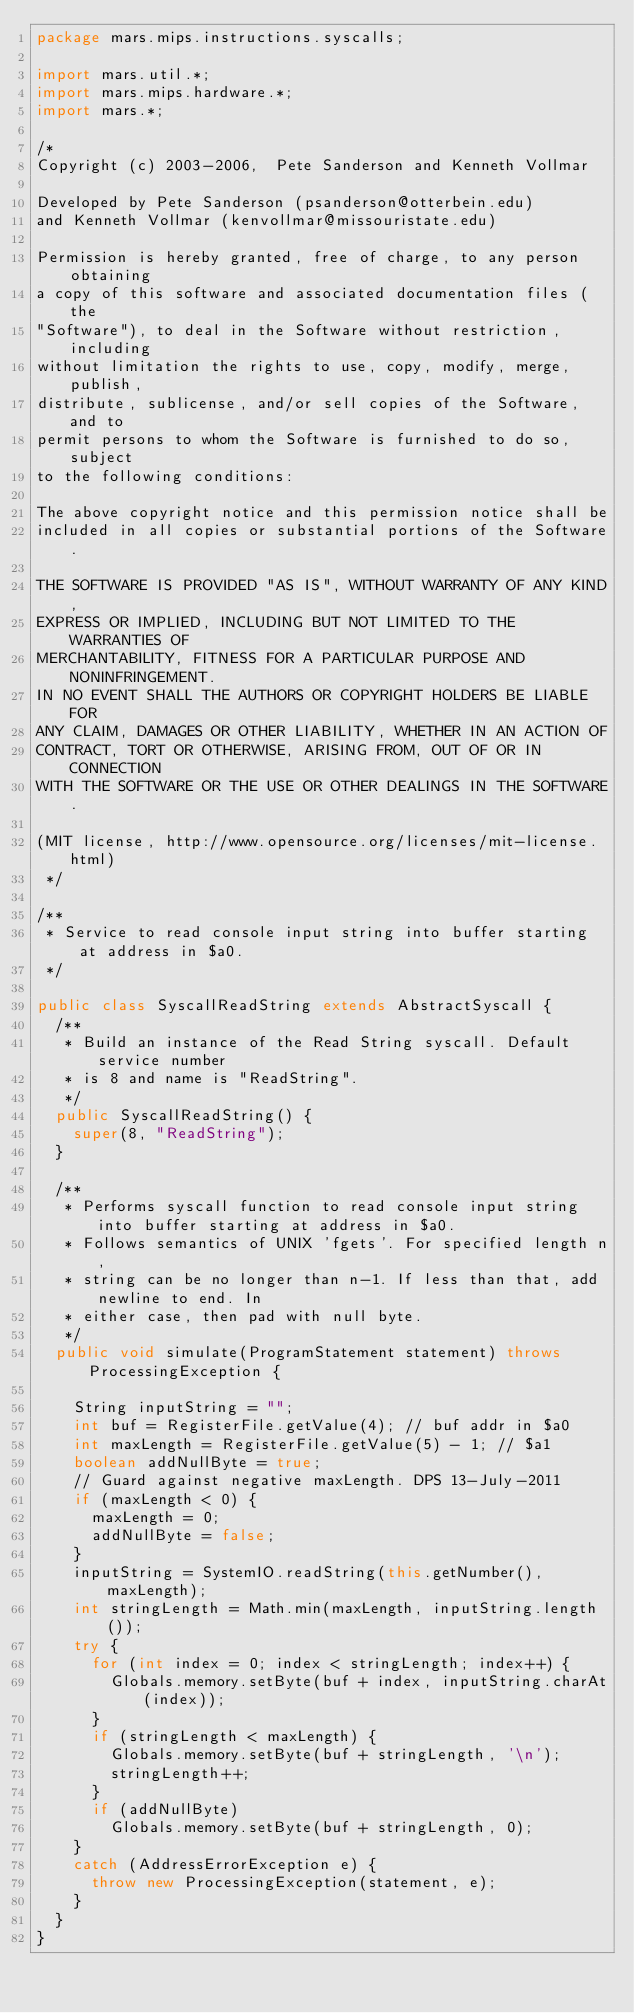<code> <loc_0><loc_0><loc_500><loc_500><_Java_>package mars.mips.instructions.syscalls;

import mars.util.*;
import mars.mips.hardware.*;
import mars.*;

/*
Copyright (c) 2003-2006,  Pete Sanderson and Kenneth Vollmar

Developed by Pete Sanderson (psanderson@otterbein.edu)
and Kenneth Vollmar (kenvollmar@missouristate.edu)

Permission is hereby granted, free of charge, to any person obtaining 
a copy of this software and associated documentation files (the 
"Software"), to deal in the Software without restriction, including 
without limitation the rights to use, copy, modify, merge, publish, 
distribute, sublicense, and/or sell copies of the Software, and to 
permit persons to whom the Software is furnished to do so, subject 
to the following conditions:

The above copyright notice and this permission notice shall be 
included in all copies or substantial portions of the Software.

THE SOFTWARE IS PROVIDED "AS IS", WITHOUT WARRANTY OF ANY KIND, 
EXPRESS OR IMPLIED, INCLUDING BUT NOT LIMITED TO THE WARRANTIES OF 
MERCHANTABILITY, FITNESS FOR A PARTICULAR PURPOSE AND NONINFRINGEMENT. 
IN NO EVENT SHALL THE AUTHORS OR COPYRIGHT HOLDERS BE LIABLE FOR 
ANY CLAIM, DAMAGES OR OTHER LIABILITY, WHETHER IN AN ACTION OF 
CONTRACT, TORT OR OTHERWISE, ARISING FROM, OUT OF OR IN CONNECTION 
WITH THE SOFTWARE OR THE USE OR OTHER DEALINGS IN THE SOFTWARE.

(MIT license, http://www.opensource.org/licenses/mit-license.html)
 */

/**
 * Service to read console input string into buffer starting at address in $a0.
 */

public class SyscallReadString extends AbstractSyscall {
	/**
	 * Build an instance of the Read String syscall. Default service number
	 * is 8 and name is "ReadString".
	 */
	public SyscallReadString() {
		super(8, "ReadString");
	}

	/**
	 * Performs syscall function to read console input string into buffer starting at address in $a0.
	 * Follows semantics of UNIX 'fgets'. For specified length n,
	 * string can be no longer than n-1. If less than that, add newline to end. In
	 * either case, then pad with null byte.
	 */
	public void simulate(ProgramStatement statement) throws ProcessingException {

		String inputString = "";
		int buf = RegisterFile.getValue(4); // buf addr in $a0
		int maxLength = RegisterFile.getValue(5) - 1; // $a1
		boolean addNullByte = true;
		// Guard against negative maxLength. DPS 13-July-2011
		if (maxLength < 0) {
			maxLength = 0;
			addNullByte = false;
		}
		inputString = SystemIO.readString(this.getNumber(), maxLength);
		int stringLength = Math.min(maxLength, inputString.length());
		try {
			for (int index = 0; index < stringLength; index++) {
				Globals.memory.setByte(buf + index, inputString.charAt(index));
			}
			if (stringLength < maxLength) {
				Globals.memory.setByte(buf + stringLength, '\n');
				stringLength++;
			}
			if (addNullByte)
				Globals.memory.setByte(buf + stringLength, 0);
		}
		catch (AddressErrorException e) {
			throw new ProcessingException(statement, e);
		}
	}
}</code> 